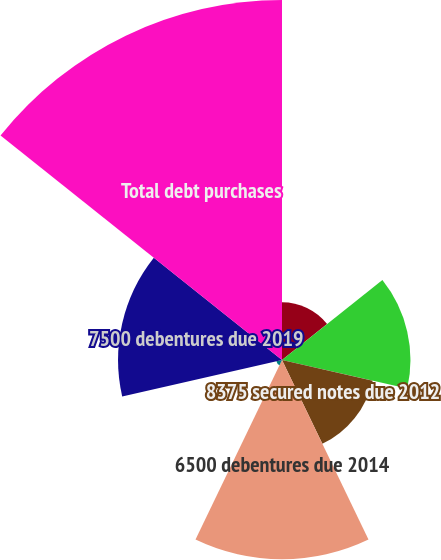<chart> <loc_0><loc_0><loc_500><loc_500><pie_chart><fcel>6000 notes due 2012<fcel>6125 notes due 2012<fcel>8375 secured notes due 2012<fcel>6500 debentures due 2014<fcel>5900 notes due 2018<fcel>7500 debentures due 2019<fcel>Total debt purchases<nl><fcel>5.72%<fcel>12.74%<fcel>9.23%<fcel>19.77%<fcel>0.57%<fcel>16.26%<fcel>35.71%<nl></chart> 